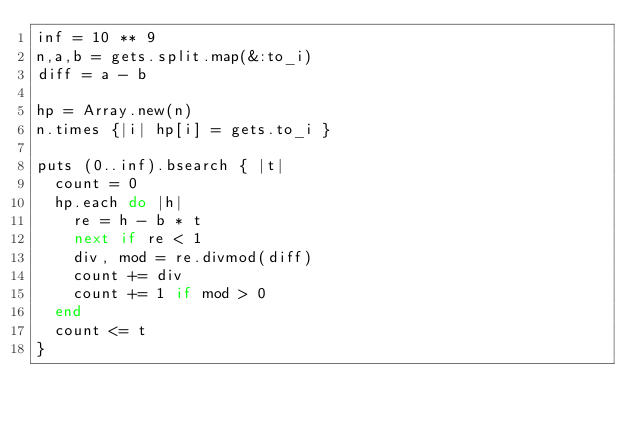Convert code to text. <code><loc_0><loc_0><loc_500><loc_500><_Ruby_>inf = 10 ** 9
n,a,b = gets.split.map(&:to_i)
diff = a - b

hp = Array.new(n)
n.times {|i| hp[i] = gets.to_i }

puts (0..inf).bsearch { |t|
  count = 0
  hp.each do |h|
    re = h - b * t
    next if re < 1
    div, mod = re.divmod(diff)
    count += div
    count += 1 if mod > 0
  end
  count <= t
}</code> 